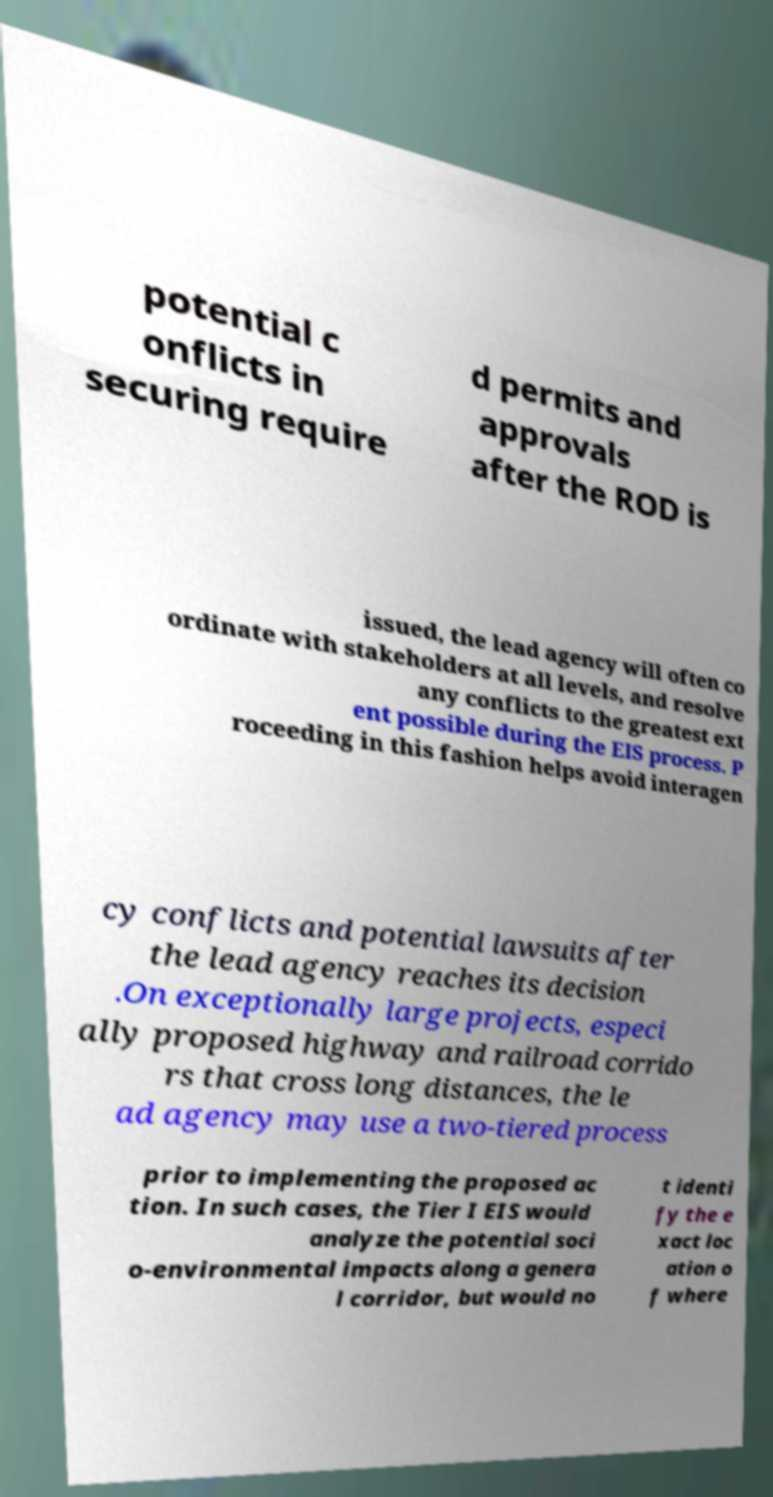I need the written content from this picture converted into text. Can you do that? potential c onflicts in securing require d permits and approvals after the ROD is issued, the lead agency will often co ordinate with stakeholders at all levels, and resolve any conflicts to the greatest ext ent possible during the EIS process. P roceeding in this fashion helps avoid interagen cy conflicts and potential lawsuits after the lead agency reaches its decision .On exceptionally large projects, especi ally proposed highway and railroad corrido rs that cross long distances, the le ad agency may use a two-tiered process prior to implementing the proposed ac tion. In such cases, the Tier I EIS would analyze the potential soci o-environmental impacts along a genera l corridor, but would no t identi fy the e xact loc ation o f where 